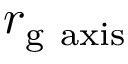<formula> <loc_0><loc_0><loc_500><loc_500>r _ { g { a x i s } }</formula> 